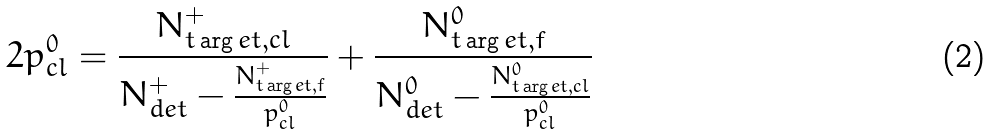Convert formula to latex. <formula><loc_0><loc_0><loc_500><loc_500>2 p _ { c l } ^ { 0 } = \frac { N _ { t \arg e t , c l } ^ { + } } { N _ { d e t } ^ { + } - \frac { N _ { t \arg e t , f } ^ { + } } { p _ { c l } ^ { 0 } } } + \frac { N _ { t \arg e t , f } ^ { 0 } } { N _ { d e t } ^ { 0 } - \frac { N _ { t \arg e t , c l } ^ { 0 } } { p _ { c l } ^ { 0 } } }</formula> 